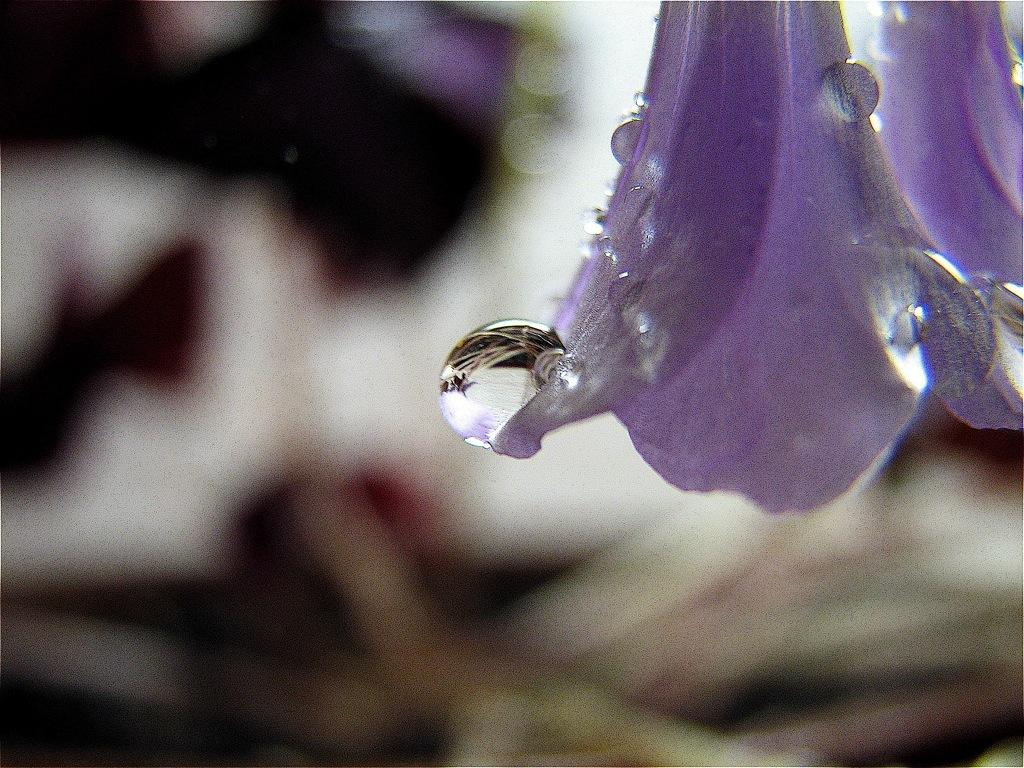How many flowers are present in the image? There are two flowers in the image. What can be observed on the flowers? There are water drops on the flowers. Can you describe the background of the image? The background of the image is blurry. What type of competition is taking place between the flowers in the image? There is no competition present in the image; it simply shows two flowers with water drops on them. 